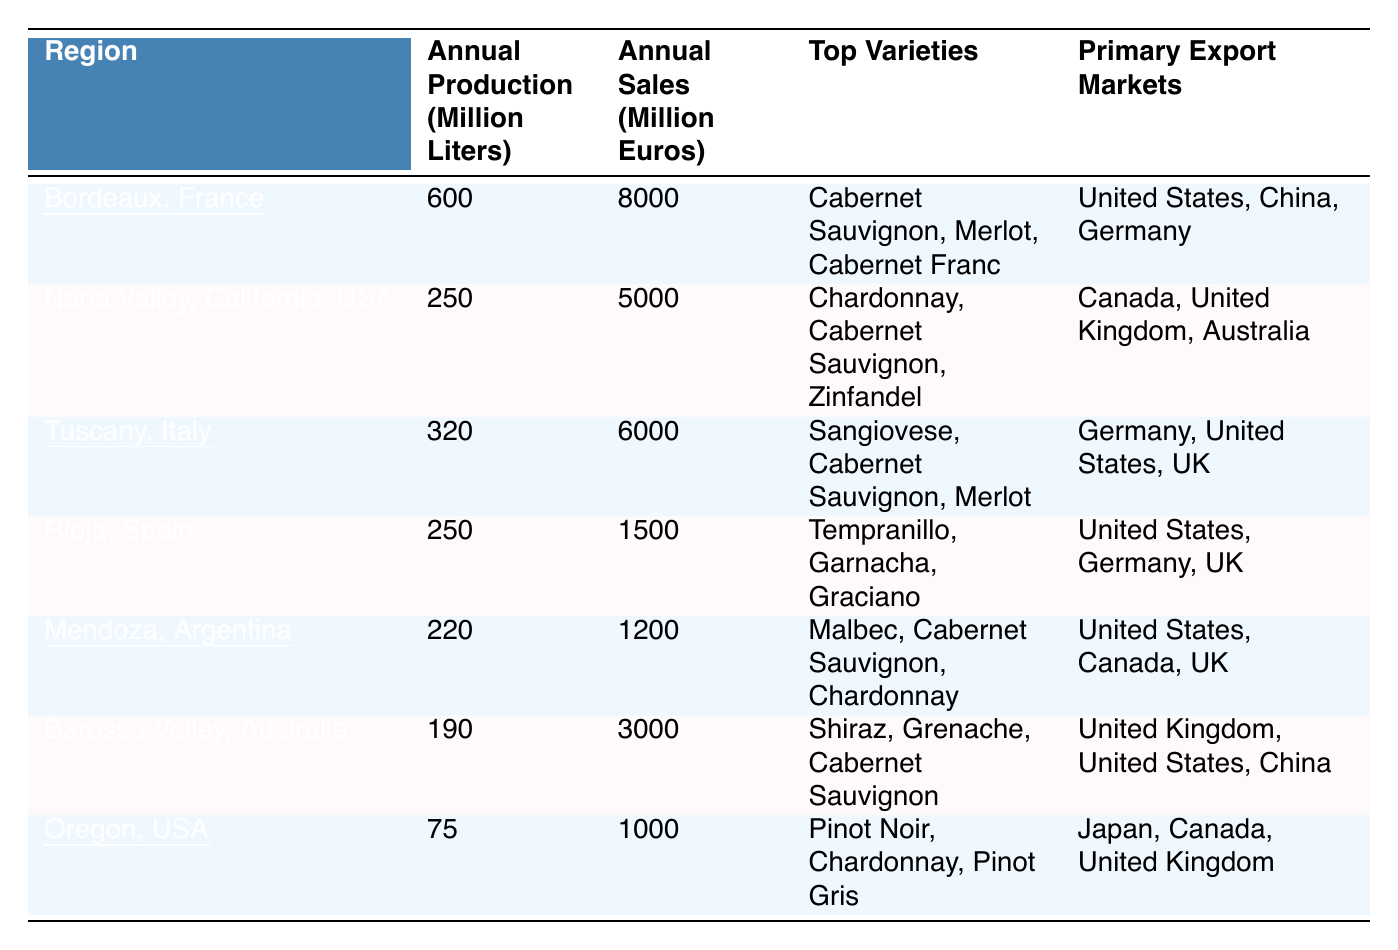What is the annual production of Bordeaux, France? According to the table, Bordeaux, France has an annual production of 600 million liters.
Answer: 600 million liters What wine region has the lowest annual sales? By reviewing the table, Mendoza, Argentina has the lowest annual sales at 1200 million euros.
Answer: Mendoza, Argentina Which region has the highest annual production? From the data, Bordeaux, France has the highest annual production at 600 million liters.
Answer: Bordeaux, France What is the total annual production of the top three wine regions (Bordeaux, Napa Valley, Tuscany)? The total annual production is the sum of the three regions: 600 (Bordeaux) + 250 (Napa Valley) + 320 (Tuscany) = 1170 million liters.
Answer: 1170 million liters Which two regions have the same annual production? The table shows that Rioja, Spain and Napa Valley, California, USA both have an annual production of 250 million liters.
Answer: Rioja and Napa Valley How much higher are the annual sales of Napa Valley than those of Mendoza? The annual sales for Napa Valley is 5000 million euros, while Mendoza is 1200 million euros. The difference is 5000 - 1200 = 3800 million euros.
Answer: 3800 million euros What percentage of the total annual production (of the seven regions) is accounted for by Tuscany? First, calculate the total production: 600 (Bordeaux) + 250 (Napa Valley) + 320 (Tuscany) + 250 (Rioja) + 220 (Mendoza) + 190 (Barossa Valley) + 75 (Oregon) = 1915 million liters. Then, calculate the percentage for Tuscany: (320 / 1915) * 100 = 16.7%.
Answer: 16.7% Which region has the top variety of Chardonnay? According to the table, Napa Valley, California, USA has Chardonnay as one of its top varieties.
Answer: Napa Valley Is it true that Barossa Valley has an annual production of more than 200 million liters? The table states Barossa Valley, Australia has an annual production of 190 million liters, which is less than 200 million liters, making the statement false.
Answer: False What are the two primary export markets for Bordeaux, France? Bordeaux, France's primary export markets as listed in the table are the United States, China, and Germany; therefore, two markets could be either United States or China, or any combination thereof.
Answer: United States, China or any pairing of two If you combine the annual sales of Oregon and Rioja, how much is it? The annual sales for Oregon is 1000 million euros and for Rioja is 1500 million euros. Adding them gives: 1000 + 1500 = 2500 million euros.
Answer: 2500 million euros 